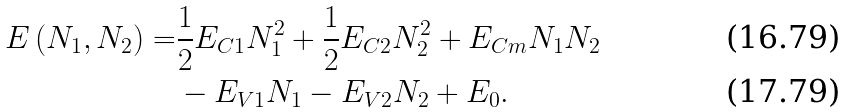<formula> <loc_0><loc_0><loc_500><loc_500>E \left ( N _ { 1 } , N _ { 2 } \right ) = & \frac { 1 } { 2 } E _ { C 1 } N _ { 1 } ^ { 2 } + \frac { 1 } { 2 } E _ { C 2 } N _ { 2 } ^ { 2 } + E _ { C m } N _ { 1 } N _ { 2 } \\ & - E _ { V 1 } N _ { 1 } - E _ { V 2 } N _ { 2 } + E _ { 0 } .</formula> 